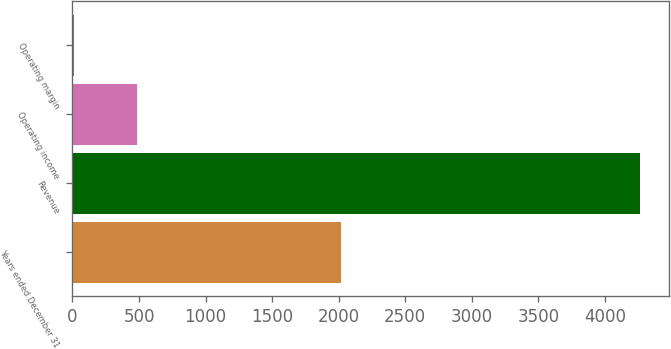Convert chart. <chart><loc_0><loc_0><loc_500><loc_500><bar_chart><fcel>Years ended December 31<fcel>Revenue<fcel>Operating income<fcel>Operating margin<nl><fcel>2014<fcel>4264<fcel>485<fcel>11.4<nl></chart> 